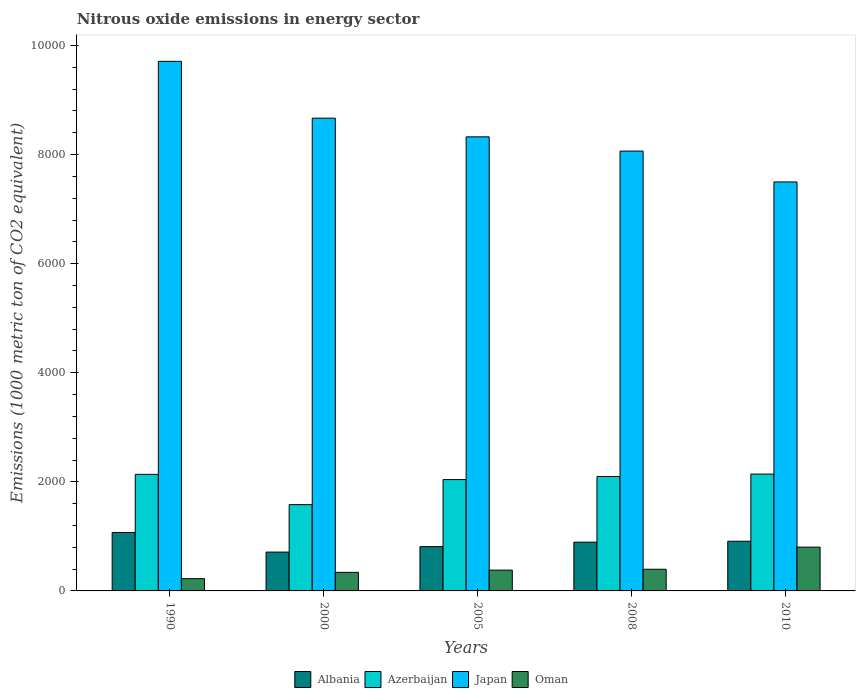How many different coloured bars are there?
Offer a very short reply. 4. How many groups of bars are there?
Your answer should be compact. 5. Are the number of bars per tick equal to the number of legend labels?
Keep it short and to the point. Yes. Are the number of bars on each tick of the X-axis equal?
Ensure brevity in your answer.  Yes. How many bars are there on the 1st tick from the right?
Ensure brevity in your answer.  4. What is the label of the 1st group of bars from the left?
Provide a succinct answer. 1990. What is the amount of nitrous oxide emitted in Japan in 1990?
Provide a short and direct response. 9708.8. Across all years, what is the maximum amount of nitrous oxide emitted in Oman?
Keep it short and to the point. 803. Across all years, what is the minimum amount of nitrous oxide emitted in Albania?
Offer a terse response. 712.1. In which year was the amount of nitrous oxide emitted in Albania maximum?
Offer a very short reply. 1990. What is the total amount of nitrous oxide emitted in Azerbaijan in the graph?
Ensure brevity in your answer.  1.00e+04. What is the difference between the amount of nitrous oxide emitted in Japan in 2000 and that in 2005?
Keep it short and to the point. 342.5. What is the difference between the amount of nitrous oxide emitted in Japan in 2000 and the amount of nitrous oxide emitted in Oman in 2010?
Offer a very short reply. 7864.2. What is the average amount of nitrous oxide emitted in Albania per year?
Your response must be concise. 880.2. In the year 2008, what is the difference between the amount of nitrous oxide emitted in Japan and amount of nitrous oxide emitted in Oman?
Provide a succinct answer. 7666.3. What is the ratio of the amount of nitrous oxide emitted in Azerbaijan in 2000 to that in 2005?
Your answer should be compact. 0.77. What is the difference between the highest and the second highest amount of nitrous oxide emitted in Japan?
Provide a succinct answer. 1041.6. What is the difference between the highest and the lowest amount of nitrous oxide emitted in Azerbaijan?
Provide a short and direct response. 560. In how many years, is the amount of nitrous oxide emitted in Albania greater than the average amount of nitrous oxide emitted in Albania taken over all years?
Provide a short and direct response. 3. Is it the case that in every year, the sum of the amount of nitrous oxide emitted in Azerbaijan and amount of nitrous oxide emitted in Albania is greater than the sum of amount of nitrous oxide emitted in Japan and amount of nitrous oxide emitted in Oman?
Offer a terse response. Yes. What does the 1st bar from the left in 1990 represents?
Keep it short and to the point. Albania. What is the difference between two consecutive major ticks on the Y-axis?
Give a very brief answer. 2000. Are the values on the major ticks of Y-axis written in scientific E-notation?
Offer a terse response. No. Does the graph contain any zero values?
Offer a very short reply. No. Does the graph contain grids?
Your answer should be compact. No. How are the legend labels stacked?
Keep it short and to the point. Horizontal. What is the title of the graph?
Make the answer very short. Nitrous oxide emissions in energy sector. Does "European Union" appear as one of the legend labels in the graph?
Provide a succinct answer. No. What is the label or title of the X-axis?
Keep it short and to the point. Years. What is the label or title of the Y-axis?
Ensure brevity in your answer.  Emissions (1000 metric ton of CO2 equivalent). What is the Emissions (1000 metric ton of CO2 equivalent) of Albania in 1990?
Offer a terse response. 1071.9. What is the Emissions (1000 metric ton of CO2 equivalent) in Azerbaijan in 1990?
Ensure brevity in your answer.  2137.1. What is the Emissions (1000 metric ton of CO2 equivalent) in Japan in 1990?
Ensure brevity in your answer.  9708.8. What is the Emissions (1000 metric ton of CO2 equivalent) of Oman in 1990?
Offer a terse response. 225. What is the Emissions (1000 metric ton of CO2 equivalent) in Albania in 2000?
Ensure brevity in your answer.  712.1. What is the Emissions (1000 metric ton of CO2 equivalent) in Azerbaijan in 2000?
Your response must be concise. 1582.1. What is the Emissions (1000 metric ton of CO2 equivalent) in Japan in 2000?
Provide a succinct answer. 8667.2. What is the Emissions (1000 metric ton of CO2 equivalent) in Oman in 2000?
Your answer should be compact. 340.4. What is the Emissions (1000 metric ton of CO2 equivalent) in Albania in 2005?
Your answer should be very brief. 812. What is the Emissions (1000 metric ton of CO2 equivalent) in Azerbaijan in 2005?
Offer a very short reply. 2041.5. What is the Emissions (1000 metric ton of CO2 equivalent) in Japan in 2005?
Give a very brief answer. 8324.7. What is the Emissions (1000 metric ton of CO2 equivalent) of Oman in 2005?
Provide a succinct answer. 381.4. What is the Emissions (1000 metric ton of CO2 equivalent) in Albania in 2008?
Keep it short and to the point. 894. What is the Emissions (1000 metric ton of CO2 equivalent) of Azerbaijan in 2008?
Give a very brief answer. 2098. What is the Emissions (1000 metric ton of CO2 equivalent) in Japan in 2008?
Offer a terse response. 8063.7. What is the Emissions (1000 metric ton of CO2 equivalent) of Oman in 2008?
Provide a short and direct response. 397.4. What is the Emissions (1000 metric ton of CO2 equivalent) in Albania in 2010?
Provide a short and direct response. 911. What is the Emissions (1000 metric ton of CO2 equivalent) in Azerbaijan in 2010?
Your answer should be very brief. 2142.1. What is the Emissions (1000 metric ton of CO2 equivalent) in Japan in 2010?
Make the answer very short. 7497.9. What is the Emissions (1000 metric ton of CO2 equivalent) of Oman in 2010?
Your response must be concise. 803. Across all years, what is the maximum Emissions (1000 metric ton of CO2 equivalent) of Albania?
Ensure brevity in your answer.  1071.9. Across all years, what is the maximum Emissions (1000 metric ton of CO2 equivalent) in Azerbaijan?
Provide a succinct answer. 2142.1. Across all years, what is the maximum Emissions (1000 metric ton of CO2 equivalent) of Japan?
Ensure brevity in your answer.  9708.8. Across all years, what is the maximum Emissions (1000 metric ton of CO2 equivalent) in Oman?
Offer a very short reply. 803. Across all years, what is the minimum Emissions (1000 metric ton of CO2 equivalent) of Albania?
Make the answer very short. 712.1. Across all years, what is the minimum Emissions (1000 metric ton of CO2 equivalent) in Azerbaijan?
Provide a succinct answer. 1582.1. Across all years, what is the minimum Emissions (1000 metric ton of CO2 equivalent) in Japan?
Offer a terse response. 7497.9. Across all years, what is the minimum Emissions (1000 metric ton of CO2 equivalent) in Oman?
Provide a short and direct response. 225. What is the total Emissions (1000 metric ton of CO2 equivalent) of Albania in the graph?
Offer a terse response. 4401. What is the total Emissions (1000 metric ton of CO2 equivalent) of Azerbaijan in the graph?
Keep it short and to the point. 1.00e+04. What is the total Emissions (1000 metric ton of CO2 equivalent) in Japan in the graph?
Your answer should be compact. 4.23e+04. What is the total Emissions (1000 metric ton of CO2 equivalent) of Oman in the graph?
Ensure brevity in your answer.  2147.2. What is the difference between the Emissions (1000 metric ton of CO2 equivalent) in Albania in 1990 and that in 2000?
Your answer should be very brief. 359.8. What is the difference between the Emissions (1000 metric ton of CO2 equivalent) in Azerbaijan in 1990 and that in 2000?
Give a very brief answer. 555. What is the difference between the Emissions (1000 metric ton of CO2 equivalent) of Japan in 1990 and that in 2000?
Make the answer very short. 1041.6. What is the difference between the Emissions (1000 metric ton of CO2 equivalent) of Oman in 1990 and that in 2000?
Ensure brevity in your answer.  -115.4. What is the difference between the Emissions (1000 metric ton of CO2 equivalent) in Albania in 1990 and that in 2005?
Your answer should be very brief. 259.9. What is the difference between the Emissions (1000 metric ton of CO2 equivalent) in Azerbaijan in 1990 and that in 2005?
Your response must be concise. 95.6. What is the difference between the Emissions (1000 metric ton of CO2 equivalent) in Japan in 1990 and that in 2005?
Your response must be concise. 1384.1. What is the difference between the Emissions (1000 metric ton of CO2 equivalent) in Oman in 1990 and that in 2005?
Give a very brief answer. -156.4. What is the difference between the Emissions (1000 metric ton of CO2 equivalent) of Albania in 1990 and that in 2008?
Make the answer very short. 177.9. What is the difference between the Emissions (1000 metric ton of CO2 equivalent) in Azerbaijan in 1990 and that in 2008?
Offer a terse response. 39.1. What is the difference between the Emissions (1000 metric ton of CO2 equivalent) of Japan in 1990 and that in 2008?
Provide a succinct answer. 1645.1. What is the difference between the Emissions (1000 metric ton of CO2 equivalent) of Oman in 1990 and that in 2008?
Provide a short and direct response. -172.4. What is the difference between the Emissions (1000 metric ton of CO2 equivalent) in Albania in 1990 and that in 2010?
Provide a succinct answer. 160.9. What is the difference between the Emissions (1000 metric ton of CO2 equivalent) in Azerbaijan in 1990 and that in 2010?
Offer a terse response. -5. What is the difference between the Emissions (1000 metric ton of CO2 equivalent) of Japan in 1990 and that in 2010?
Provide a short and direct response. 2210.9. What is the difference between the Emissions (1000 metric ton of CO2 equivalent) in Oman in 1990 and that in 2010?
Offer a terse response. -578. What is the difference between the Emissions (1000 metric ton of CO2 equivalent) in Albania in 2000 and that in 2005?
Offer a very short reply. -99.9. What is the difference between the Emissions (1000 metric ton of CO2 equivalent) in Azerbaijan in 2000 and that in 2005?
Give a very brief answer. -459.4. What is the difference between the Emissions (1000 metric ton of CO2 equivalent) in Japan in 2000 and that in 2005?
Make the answer very short. 342.5. What is the difference between the Emissions (1000 metric ton of CO2 equivalent) of Oman in 2000 and that in 2005?
Provide a succinct answer. -41. What is the difference between the Emissions (1000 metric ton of CO2 equivalent) of Albania in 2000 and that in 2008?
Offer a very short reply. -181.9. What is the difference between the Emissions (1000 metric ton of CO2 equivalent) in Azerbaijan in 2000 and that in 2008?
Offer a terse response. -515.9. What is the difference between the Emissions (1000 metric ton of CO2 equivalent) in Japan in 2000 and that in 2008?
Keep it short and to the point. 603.5. What is the difference between the Emissions (1000 metric ton of CO2 equivalent) in Oman in 2000 and that in 2008?
Your response must be concise. -57. What is the difference between the Emissions (1000 metric ton of CO2 equivalent) in Albania in 2000 and that in 2010?
Your response must be concise. -198.9. What is the difference between the Emissions (1000 metric ton of CO2 equivalent) of Azerbaijan in 2000 and that in 2010?
Make the answer very short. -560. What is the difference between the Emissions (1000 metric ton of CO2 equivalent) of Japan in 2000 and that in 2010?
Make the answer very short. 1169.3. What is the difference between the Emissions (1000 metric ton of CO2 equivalent) in Oman in 2000 and that in 2010?
Keep it short and to the point. -462.6. What is the difference between the Emissions (1000 metric ton of CO2 equivalent) of Albania in 2005 and that in 2008?
Keep it short and to the point. -82. What is the difference between the Emissions (1000 metric ton of CO2 equivalent) in Azerbaijan in 2005 and that in 2008?
Provide a short and direct response. -56.5. What is the difference between the Emissions (1000 metric ton of CO2 equivalent) in Japan in 2005 and that in 2008?
Your answer should be compact. 261. What is the difference between the Emissions (1000 metric ton of CO2 equivalent) of Albania in 2005 and that in 2010?
Your answer should be compact. -99. What is the difference between the Emissions (1000 metric ton of CO2 equivalent) in Azerbaijan in 2005 and that in 2010?
Your answer should be very brief. -100.6. What is the difference between the Emissions (1000 metric ton of CO2 equivalent) of Japan in 2005 and that in 2010?
Provide a succinct answer. 826.8. What is the difference between the Emissions (1000 metric ton of CO2 equivalent) in Oman in 2005 and that in 2010?
Offer a very short reply. -421.6. What is the difference between the Emissions (1000 metric ton of CO2 equivalent) in Azerbaijan in 2008 and that in 2010?
Your response must be concise. -44.1. What is the difference between the Emissions (1000 metric ton of CO2 equivalent) in Japan in 2008 and that in 2010?
Give a very brief answer. 565.8. What is the difference between the Emissions (1000 metric ton of CO2 equivalent) of Oman in 2008 and that in 2010?
Give a very brief answer. -405.6. What is the difference between the Emissions (1000 metric ton of CO2 equivalent) in Albania in 1990 and the Emissions (1000 metric ton of CO2 equivalent) in Azerbaijan in 2000?
Offer a terse response. -510.2. What is the difference between the Emissions (1000 metric ton of CO2 equivalent) in Albania in 1990 and the Emissions (1000 metric ton of CO2 equivalent) in Japan in 2000?
Give a very brief answer. -7595.3. What is the difference between the Emissions (1000 metric ton of CO2 equivalent) in Albania in 1990 and the Emissions (1000 metric ton of CO2 equivalent) in Oman in 2000?
Provide a succinct answer. 731.5. What is the difference between the Emissions (1000 metric ton of CO2 equivalent) in Azerbaijan in 1990 and the Emissions (1000 metric ton of CO2 equivalent) in Japan in 2000?
Offer a very short reply. -6530.1. What is the difference between the Emissions (1000 metric ton of CO2 equivalent) in Azerbaijan in 1990 and the Emissions (1000 metric ton of CO2 equivalent) in Oman in 2000?
Ensure brevity in your answer.  1796.7. What is the difference between the Emissions (1000 metric ton of CO2 equivalent) of Japan in 1990 and the Emissions (1000 metric ton of CO2 equivalent) of Oman in 2000?
Give a very brief answer. 9368.4. What is the difference between the Emissions (1000 metric ton of CO2 equivalent) in Albania in 1990 and the Emissions (1000 metric ton of CO2 equivalent) in Azerbaijan in 2005?
Keep it short and to the point. -969.6. What is the difference between the Emissions (1000 metric ton of CO2 equivalent) in Albania in 1990 and the Emissions (1000 metric ton of CO2 equivalent) in Japan in 2005?
Give a very brief answer. -7252.8. What is the difference between the Emissions (1000 metric ton of CO2 equivalent) of Albania in 1990 and the Emissions (1000 metric ton of CO2 equivalent) of Oman in 2005?
Ensure brevity in your answer.  690.5. What is the difference between the Emissions (1000 metric ton of CO2 equivalent) in Azerbaijan in 1990 and the Emissions (1000 metric ton of CO2 equivalent) in Japan in 2005?
Your answer should be very brief. -6187.6. What is the difference between the Emissions (1000 metric ton of CO2 equivalent) of Azerbaijan in 1990 and the Emissions (1000 metric ton of CO2 equivalent) of Oman in 2005?
Give a very brief answer. 1755.7. What is the difference between the Emissions (1000 metric ton of CO2 equivalent) of Japan in 1990 and the Emissions (1000 metric ton of CO2 equivalent) of Oman in 2005?
Offer a terse response. 9327.4. What is the difference between the Emissions (1000 metric ton of CO2 equivalent) in Albania in 1990 and the Emissions (1000 metric ton of CO2 equivalent) in Azerbaijan in 2008?
Offer a terse response. -1026.1. What is the difference between the Emissions (1000 metric ton of CO2 equivalent) of Albania in 1990 and the Emissions (1000 metric ton of CO2 equivalent) of Japan in 2008?
Provide a succinct answer. -6991.8. What is the difference between the Emissions (1000 metric ton of CO2 equivalent) in Albania in 1990 and the Emissions (1000 metric ton of CO2 equivalent) in Oman in 2008?
Ensure brevity in your answer.  674.5. What is the difference between the Emissions (1000 metric ton of CO2 equivalent) of Azerbaijan in 1990 and the Emissions (1000 metric ton of CO2 equivalent) of Japan in 2008?
Keep it short and to the point. -5926.6. What is the difference between the Emissions (1000 metric ton of CO2 equivalent) in Azerbaijan in 1990 and the Emissions (1000 metric ton of CO2 equivalent) in Oman in 2008?
Ensure brevity in your answer.  1739.7. What is the difference between the Emissions (1000 metric ton of CO2 equivalent) in Japan in 1990 and the Emissions (1000 metric ton of CO2 equivalent) in Oman in 2008?
Your answer should be compact. 9311.4. What is the difference between the Emissions (1000 metric ton of CO2 equivalent) of Albania in 1990 and the Emissions (1000 metric ton of CO2 equivalent) of Azerbaijan in 2010?
Offer a very short reply. -1070.2. What is the difference between the Emissions (1000 metric ton of CO2 equivalent) in Albania in 1990 and the Emissions (1000 metric ton of CO2 equivalent) in Japan in 2010?
Make the answer very short. -6426. What is the difference between the Emissions (1000 metric ton of CO2 equivalent) in Albania in 1990 and the Emissions (1000 metric ton of CO2 equivalent) in Oman in 2010?
Provide a succinct answer. 268.9. What is the difference between the Emissions (1000 metric ton of CO2 equivalent) of Azerbaijan in 1990 and the Emissions (1000 metric ton of CO2 equivalent) of Japan in 2010?
Ensure brevity in your answer.  -5360.8. What is the difference between the Emissions (1000 metric ton of CO2 equivalent) of Azerbaijan in 1990 and the Emissions (1000 metric ton of CO2 equivalent) of Oman in 2010?
Give a very brief answer. 1334.1. What is the difference between the Emissions (1000 metric ton of CO2 equivalent) in Japan in 1990 and the Emissions (1000 metric ton of CO2 equivalent) in Oman in 2010?
Your answer should be very brief. 8905.8. What is the difference between the Emissions (1000 metric ton of CO2 equivalent) of Albania in 2000 and the Emissions (1000 metric ton of CO2 equivalent) of Azerbaijan in 2005?
Ensure brevity in your answer.  -1329.4. What is the difference between the Emissions (1000 metric ton of CO2 equivalent) in Albania in 2000 and the Emissions (1000 metric ton of CO2 equivalent) in Japan in 2005?
Your response must be concise. -7612.6. What is the difference between the Emissions (1000 metric ton of CO2 equivalent) in Albania in 2000 and the Emissions (1000 metric ton of CO2 equivalent) in Oman in 2005?
Offer a terse response. 330.7. What is the difference between the Emissions (1000 metric ton of CO2 equivalent) in Azerbaijan in 2000 and the Emissions (1000 metric ton of CO2 equivalent) in Japan in 2005?
Provide a short and direct response. -6742.6. What is the difference between the Emissions (1000 metric ton of CO2 equivalent) of Azerbaijan in 2000 and the Emissions (1000 metric ton of CO2 equivalent) of Oman in 2005?
Provide a short and direct response. 1200.7. What is the difference between the Emissions (1000 metric ton of CO2 equivalent) of Japan in 2000 and the Emissions (1000 metric ton of CO2 equivalent) of Oman in 2005?
Your response must be concise. 8285.8. What is the difference between the Emissions (1000 metric ton of CO2 equivalent) in Albania in 2000 and the Emissions (1000 metric ton of CO2 equivalent) in Azerbaijan in 2008?
Ensure brevity in your answer.  -1385.9. What is the difference between the Emissions (1000 metric ton of CO2 equivalent) of Albania in 2000 and the Emissions (1000 metric ton of CO2 equivalent) of Japan in 2008?
Provide a succinct answer. -7351.6. What is the difference between the Emissions (1000 metric ton of CO2 equivalent) of Albania in 2000 and the Emissions (1000 metric ton of CO2 equivalent) of Oman in 2008?
Keep it short and to the point. 314.7. What is the difference between the Emissions (1000 metric ton of CO2 equivalent) of Azerbaijan in 2000 and the Emissions (1000 metric ton of CO2 equivalent) of Japan in 2008?
Your answer should be compact. -6481.6. What is the difference between the Emissions (1000 metric ton of CO2 equivalent) in Azerbaijan in 2000 and the Emissions (1000 metric ton of CO2 equivalent) in Oman in 2008?
Your answer should be compact. 1184.7. What is the difference between the Emissions (1000 metric ton of CO2 equivalent) of Japan in 2000 and the Emissions (1000 metric ton of CO2 equivalent) of Oman in 2008?
Your answer should be very brief. 8269.8. What is the difference between the Emissions (1000 metric ton of CO2 equivalent) of Albania in 2000 and the Emissions (1000 metric ton of CO2 equivalent) of Azerbaijan in 2010?
Your answer should be compact. -1430. What is the difference between the Emissions (1000 metric ton of CO2 equivalent) in Albania in 2000 and the Emissions (1000 metric ton of CO2 equivalent) in Japan in 2010?
Offer a very short reply. -6785.8. What is the difference between the Emissions (1000 metric ton of CO2 equivalent) of Albania in 2000 and the Emissions (1000 metric ton of CO2 equivalent) of Oman in 2010?
Provide a short and direct response. -90.9. What is the difference between the Emissions (1000 metric ton of CO2 equivalent) in Azerbaijan in 2000 and the Emissions (1000 metric ton of CO2 equivalent) in Japan in 2010?
Make the answer very short. -5915.8. What is the difference between the Emissions (1000 metric ton of CO2 equivalent) of Azerbaijan in 2000 and the Emissions (1000 metric ton of CO2 equivalent) of Oman in 2010?
Offer a very short reply. 779.1. What is the difference between the Emissions (1000 metric ton of CO2 equivalent) in Japan in 2000 and the Emissions (1000 metric ton of CO2 equivalent) in Oman in 2010?
Your answer should be very brief. 7864.2. What is the difference between the Emissions (1000 metric ton of CO2 equivalent) of Albania in 2005 and the Emissions (1000 metric ton of CO2 equivalent) of Azerbaijan in 2008?
Your answer should be very brief. -1286. What is the difference between the Emissions (1000 metric ton of CO2 equivalent) of Albania in 2005 and the Emissions (1000 metric ton of CO2 equivalent) of Japan in 2008?
Keep it short and to the point. -7251.7. What is the difference between the Emissions (1000 metric ton of CO2 equivalent) in Albania in 2005 and the Emissions (1000 metric ton of CO2 equivalent) in Oman in 2008?
Keep it short and to the point. 414.6. What is the difference between the Emissions (1000 metric ton of CO2 equivalent) in Azerbaijan in 2005 and the Emissions (1000 metric ton of CO2 equivalent) in Japan in 2008?
Your response must be concise. -6022.2. What is the difference between the Emissions (1000 metric ton of CO2 equivalent) of Azerbaijan in 2005 and the Emissions (1000 metric ton of CO2 equivalent) of Oman in 2008?
Ensure brevity in your answer.  1644.1. What is the difference between the Emissions (1000 metric ton of CO2 equivalent) of Japan in 2005 and the Emissions (1000 metric ton of CO2 equivalent) of Oman in 2008?
Provide a succinct answer. 7927.3. What is the difference between the Emissions (1000 metric ton of CO2 equivalent) of Albania in 2005 and the Emissions (1000 metric ton of CO2 equivalent) of Azerbaijan in 2010?
Provide a succinct answer. -1330.1. What is the difference between the Emissions (1000 metric ton of CO2 equivalent) in Albania in 2005 and the Emissions (1000 metric ton of CO2 equivalent) in Japan in 2010?
Give a very brief answer. -6685.9. What is the difference between the Emissions (1000 metric ton of CO2 equivalent) in Azerbaijan in 2005 and the Emissions (1000 metric ton of CO2 equivalent) in Japan in 2010?
Keep it short and to the point. -5456.4. What is the difference between the Emissions (1000 metric ton of CO2 equivalent) in Azerbaijan in 2005 and the Emissions (1000 metric ton of CO2 equivalent) in Oman in 2010?
Ensure brevity in your answer.  1238.5. What is the difference between the Emissions (1000 metric ton of CO2 equivalent) in Japan in 2005 and the Emissions (1000 metric ton of CO2 equivalent) in Oman in 2010?
Your response must be concise. 7521.7. What is the difference between the Emissions (1000 metric ton of CO2 equivalent) of Albania in 2008 and the Emissions (1000 metric ton of CO2 equivalent) of Azerbaijan in 2010?
Provide a succinct answer. -1248.1. What is the difference between the Emissions (1000 metric ton of CO2 equivalent) of Albania in 2008 and the Emissions (1000 metric ton of CO2 equivalent) of Japan in 2010?
Provide a short and direct response. -6603.9. What is the difference between the Emissions (1000 metric ton of CO2 equivalent) of Albania in 2008 and the Emissions (1000 metric ton of CO2 equivalent) of Oman in 2010?
Offer a very short reply. 91. What is the difference between the Emissions (1000 metric ton of CO2 equivalent) of Azerbaijan in 2008 and the Emissions (1000 metric ton of CO2 equivalent) of Japan in 2010?
Keep it short and to the point. -5399.9. What is the difference between the Emissions (1000 metric ton of CO2 equivalent) of Azerbaijan in 2008 and the Emissions (1000 metric ton of CO2 equivalent) of Oman in 2010?
Your response must be concise. 1295. What is the difference between the Emissions (1000 metric ton of CO2 equivalent) in Japan in 2008 and the Emissions (1000 metric ton of CO2 equivalent) in Oman in 2010?
Make the answer very short. 7260.7. What is the average Emissions (1000 metric ton of CO2 equivalent) in Albania per year?
Ensure brevity in your answer.  880.2. What is the average Emissions (1000 metric ton of CO2 equivalent) of Azerbaijan per year?
Your answer should be very brief. 2000.16. What is the average Emissions (1000 metric ton of CO2 equivalent) in Japan per year?
Make the answer very short. 8452.46. What is the average Emissions (1000 metric ton of CO2 equivalent) in Oman per year?
Ensure brevity in your answer.  429.44. In the year 1990, what is the difference between the Emissions (1000 metric ton of CO2 equivalent) of Albania and Emissions (1000 metric ton of CO2 equivalent) of Azerbaijan?
Give a very brief answer. -1065.2. In the year 1990, what is the difference between the Emissions (1000 metric ton of CO2 equivalent) of Albania and Emissions (1000 metric ton of CO2 equivalent) of Japan?
Ensure brevity in your answer.  -8636.9. In the year 1990, what is the difference between the Emissions (1000 metric ton of CO2 equivalent) in Albania and Emissions (1000 metric ton of CO2 equivalent) in Oman?
Offer a terse response. 846.9. In the year 1990, what is the difference between the Emissions (1000 metric ton of CO2 equivalent) in Azerbaijan and Emissions (1000 metric ton of CO2 equivalent) in Japan?
Your answer should be compact. -7571.7. In the year 1990, what is the difference between the Emissions (1000 metric ton of CO2 equivalent) in Azerbaijan and Emissions (1000 metric ton of CO2 equivalent) in Oman?
Your answer should be very brief. 1912.1. In the year 1990, what is the difference between the Emissions (1000 metric ton of CO2 equivalent) of Japan and Emissions (1000 metric ton of CO2 equivalent) of Oman?
Your answer should be very brief. 9483.8. In the year 2000, what is the difference between the Emissions (1000 metric ton of CO2 equivalent) in Albania and Emissions (1000 metric ton of CO2 equivalent) in Azerbaijan?
Your response must be concise. -870. In the year 2000, what is the difference between the Emissions (1000 metric ton of CO2 equivalent) in Albania and Emissions (1000 metric ton of CO2 equivalent) in Japan?
Your answer should be very brief. -7955.1. In the year 2000, what is the difference between the Emissions (1000 metric ton of CO2 equivalent) of Albania and Emissions (1000 metric ton of CO2 equivalent) of Oman?
Ensure brevity in your answer.  371.7. In the year 2000, what is the difference between the Emissions (1000 metric ton of CO2 equivalent) of Azerbaijan and Emissions (1000 metric ton of CO2 equivalent) of Japan?
Provide a short and direct response. -7085.1. In the year 2000, what is the difference between the Emissions (1000 metric ton of CO2 equivalent) of Azerbaijan and Emissions (1000 metric ton of CO2 equivalent) of Oman?
Give a very brief answer. 1241.7. In the year 2000, what is the difference between the Emissions (1000 metric ton of CO2 equivalent) in Japan and Emissions (1000 metric ton of CO2 equivalent) in Oman?
Provide a short and direct response. 8326.8. In the year 2005, what is the difference between the Emissions (1000 metric ton of CO2 equivalent) of Albania and Emissions (1000 metric ton of CO2 equivalent) of Azerbaijan?
Your response must be concise. -1229.5. In the year 2005, what is the difference between the Emissions (1000 metric ton of CO2 equivalent) of Albania and Emissions (1000 metric ton of CO2 equivalent) of Japan?
Keep it short and to the point. -7512.7. In the year 2005, what is the difference between the Emissions (1000 metric ton of CO2 equivalent) of Albania and Emissions (1000 metric ton of CO2 equivalent) of Oman?
Your answer should be compact. 430.6. In the year 2005, what is the difference between the Emissions (1000 metric ton of CO2 equivalent) of Azerbaijan and Emissions (1000 metric ton of CO2 equivalent) of Japan?
Your answer should be compact. -6283.2. In the year 2005, what is the difference between the Emissions (1000 metric ton of CO2 equivalent) of Azerbaijan and Emissions (1000 metric ton of CO2 equivalent) of Oman?
Keep it short and to the point. 1660.1. In the year 2005, what is the difference between the Emissions (1000 metric ton of CO2 equivalent) in Japan and Emissions (1000 metric ton of CO2 equivalent) in Oman?
Keep it short and to the point. 7943.3. In the year 2008, what is the difference between the Emissions (1000 metric ton of CO2 equivalent) in Albania and Emissions (1000 metric ton of CO2 equivalent) in Azerbaijan?
Your response must be concise. -1204. In the year 2008, what is the difference between the Emissions (1000 metric ton of CO2 equivalent) in Albania and Emissions (1000 metric ton of CO2 equivalent) in Japan?
Your answer should be very brief. -7169.7. In the year 2008, what is the difference between the Emissions (1000 metric ton of CO2 equivalent) of Albania and Emissions (1000 metric ton of CO2 equivalent) of Oman?
Keep it short and to the point. 496.6. In the year 2008, what is the difference between the Emissions (1000 metric ton of CO2 equivalent) of Azerbaijan and Emissions (1000 metric ton of CO2 equivalent) of Japan?
Your answer should be compact. -5965.7. In the year 2008, what is the difference between the Emissions (1000 metric ton of CO2 equivalent) in Azerbaijan and Emissions (1000 metric ton of CO2 equivalent) in Oman?
Keep it short and to the point. 1700.6. In the year 2008, what is the difference between the Emissions (1000 metric ton of CO2 equivalent) of Japan and Emissions (1000 metric ton of CO2 equivalent) of Oman?
Keep it short and to the point. 7666.3. In the year 2010, what is the difference between the Emissions (1000 metric ton of CO2 equivalent) of Albania and Emissions (1000 metric ton of CO2 equivalent) of Azerbaijan?
Your answer should be compact. -1231.1. In the year 2010, what is the difference between the Emissions (1000 metric ton of CO2 equivalent) in Albania and Emissions (1000 metric ton of CO2 equivalent) in Japan?
Your answer should be compact. -6586.9. In the year 2010, what is the difference between the Emissions (1000 metric ton of CO2 equivalent) in Albania and Emissions (1000 metric ton of CO2 equivalent) in Oman?
Your answer should be compact. 108. In the year 2010, what is the difference between the Emissions (1000 metric ton of CO2 equivalent) in Azerbaijan and Emissions (1000 metric ton of CO2 equivalent) in Japan?
Provide a succinct answer. -5355.8. In the year 2010, what is the difference between the Emissions (1000 metric ton of CO2 equivalent) of Azerbaijan and Emissions (1000 metric ton of CO2 equivalent) of Oman?
Offer a terse response. 1339.1. In the year 2010, what is the difference between the Emissions (1000 metric ton of CO2 equivalent) of Japan and Emissions (1000 metric ton of CO2 equivalent) of Oman?
Keep it short and to the point. 6694.9. What is the ratio of the Emissions (1000 metric ton of CO2 equivalent) of Albania in 1990 to that in 2000?
Provide a succinct answer. 1.51. What is the ratio of the Emissions (1000 metric ton of CO2 equivalent) in Azerbaijan in 1990 to that in 2000?
Provide a succinct answer. 1.35. What is the ratio of the Emissions (1000 metric ton of CO2 equivalent) of Japan in 1990 to that in 2000?
Provide a short and direct response. 1.12. What is the ratio of the Emissions (1000 metric ton of CO2 equivalent) in Oman in 1990 to that in 2000?
Your answer should be very brief. 0.66. What is the ratio of the Emissions (1000 metric ton of CO2 equivalent) of Albania in 1990 to that in 2005?
Provide a succinct answer. 1.32. What is the ratio of the Emissions (1000 metric ton of CO2 equivalent) in Azerbaijan in 1990 to that in 2005?
Offer a terse response. 1.05. What is the ratio of the Emissions (1000 metric ton of CO2 equivalent) of Japan in 1990 to that in 2005?
Your response must be concise. 1.17. What is the ratio of the Emissions (1000 metric ton of CO2 equivalent) in Oman in 1990 to that in 2005?
Your answer should be compact. 0.59. What is the ratio of the Emissions (1000 metric ton of CO2 equivalent) of Albania in 1990 to that in 2008?
Your answer should be compact. 1.2. What is the ratio of the Emissions (1000 metric ton of CO2 equivalent) in Azerbaijan in 1990 to that in 2008?
Give a very brief answer. 1.02. What is the ratio of the Emissions (1000 metric ton of CO2 equivalent) in Japan in 1990 to that in 2008?
Provide a succinct answer. 1.2. What is the ratio of the Emissions (1000 metric ton of CO2 equivalent) in Oman in 1990 to that in 2008?
Your answer should be compact. 0.57. What is the ratio of the Emissions (1000 metric ton of CO2 equivalent) of Albania in 1990 to that in 2010?
Ensure brevity in your answer.  1.18. What is the ratio of the Emissions (1000 metric ton of CO2 equivalent) in Azerbaijan in 1990 to that in 2010?
Offer a terse response. 1. What is the ratio of the Emissions (1000 metric ton of CO2 equivalent) in Japan in 1990 to that in 2010?
Make the answer very short. 1.29. What is the ratio of the Emissions (1000 metric ton of CO2 equivalent) in Oman in 1990 to that in 2010?
Make the answer very short. 0.28. What is the ratio of the Emissions (1000 metric ton of CO2 equivalent) in Albania in 2000 to that in 2005?
Ensure brevity in your answer.  0.88. What is the ratio of the Emissions (1000 metric ton of CO2 equivalent) of Azerbaijan in 2000 to that in 2005?
Your answer should be very brief. 0.78. What is the ratio of the Emissions (1000 metric ton of CO2 equivalent) in Japan in 2000 to that in 2005?
Provide a short and direct response. 1.04. What is the ratio of the Emissions (1000 metric ton of CO2 equivalent) of Oman in 2000 to that in 2005?
Your answer should be compact. 0.89. What is the ratio of the Emissions (1000 metric ton of CO2 equivalent) of Albania in 2000 to that in 2008?
Your answer should be very brief. 0.8. What is the ratio of the Emissions (1000 metric ton of CO2 equivalent) of Azerbaijan in 2000 to that in 2008?
Provide a short and direct response. 0.75. What is the ratio of the Emissions (1000 metric ton of CO2 equivalent) of Japan in 2000 to that in 2008?
Keep it short and to the point. 1.07. What is the ratio of the Emissions (1000 metric ton of CO2 equivalent) of Oman in 2000 to that in 2008?
Your answer should be very brief. 0.86. What is the ratio of the Emissions (1000 metric ton of CO2 equivalent) of Albania in 2000 to that in 2010?
Make the answer very short. 0.78. What is the ratio of the Emissions (1000 metric ton of CO2 equivalent) in Azerbaijan in 2000 to that in 2010?
Give a very brief answer. 0.74. What is the ratio of the Emissions (1000 metric ton of CO2 equivalent) of Japan in 2000 to that in 2010?
Offer a terse response. 1.16. What is the ratio of the Emissions (1000 metric ton of CO2 equivalent) in Oman in 2000 to that in 2010?
Provide a succinct answer. 0.42. What is the ratio of the Emissions (1000 metric ton of CO2 equivalent) in Albania in 2005 to that in 2008?
Your answer should be compact. 0.91. What is the ratio of the Emissions (1000 metric ton of CO2 equivalent) in Azerbaijan in 2005 to that in 2008?
Provide a succinct answer. 0.97. What is the ratio of the Emissions (1000 metric ton of CO2 equivalent) of Japan in 2005 to that in 2008?
Your answer should be compact. 1.03. What is the ratio of the Emissions (1000 metric ton of CO2 equivalent) in Oman in 2005 to that in 2008?
Keep it short and to the point. 0.96. What is the ratio of the Emissions (1000 metric ton of CO2 equivalent) in Albania in 2005 to that in 2010?
Make the answer very short. 0.89. What is the ratio of the Emissions (1000 metric ton of CO2 equivalent) in Azerbaijan in 2005 to that in 2010?
Ensure brevity in your answer.  0.95. What is the ratio of the Emissions (1000 metric ton of CO2 equivalent) of Japan in 2005 to that in 2010?
Your response must be concise. 1.11. What is the ratio of the Emissions (1000 metric ton of CO2 equivalent) of Oman in 2005 to that in 2010?
Your response must be concise. 0.47. What is the ratio of the Emissions (1000 metric ton of CO2 equivalent) of Albania in 2008 to that in 2010?
Keep it short and to the point. 0.98. What is the ratio of the Emissions (1000 metric ton of CO2 equivalent) of Azerbaijan in 2008 to that in 2010?
Offer a very short reply. 0.98. What is the ratio of the Emissions (1000 metric ton of CO2 equivalent) in Japan in 2008 to that in 2010?
Provide a succinct answer. 1.08. What is the ratio of the Emissions (1000 metric ton of CO2 equivalent) in Oman in 2008 to that in 2010?
Keep it short and to the point. 0.49. What is the difference between the highest and the second highest Emissions (1000 metric ton of CO2 equivalent) in Albania?
Your response must be concise. 160.9. What is the difference between the highest and the second highest Emissions (1000 metric ton of CO2 equivalent) in Japan?
Your answer should be compact. 1041.6. What is the difference between the highest and the second highest Emissions (1000 metric ton of CO2 equivalent) in Oman?
Your answer should be compact. 405.6. What is the difference between the highest and the lowest Emissions (1000 metric ton of CO2 equivalent) in Albania?
Your response must be concise. 359.8. What is the difference between the highest and the lowest Emissions (1000 metric ton of CO2 equivalent) in Azerbaijan?
Offer a very short reply. 560. What is the difference between the highest and the lowest Emissions (1000 metric ton of CO2 equivalent) of Japan?
Your response must be concise. 2210.9. What is the difference between the highest and the lowest Emissions (1000 metric ton of CO2 equivalent) of Oman?
Provide a short and direct response. 578. 